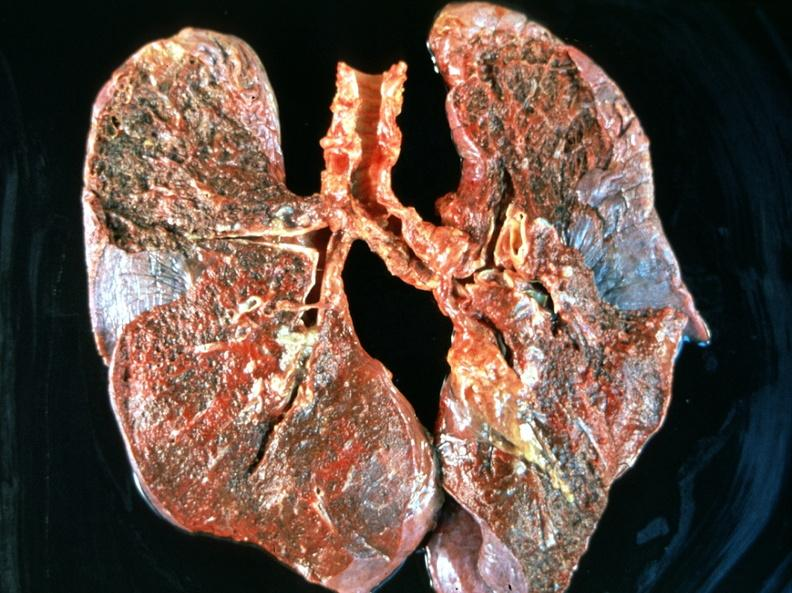what is present?
Answer the question using a single word or phrase. Respiratory 